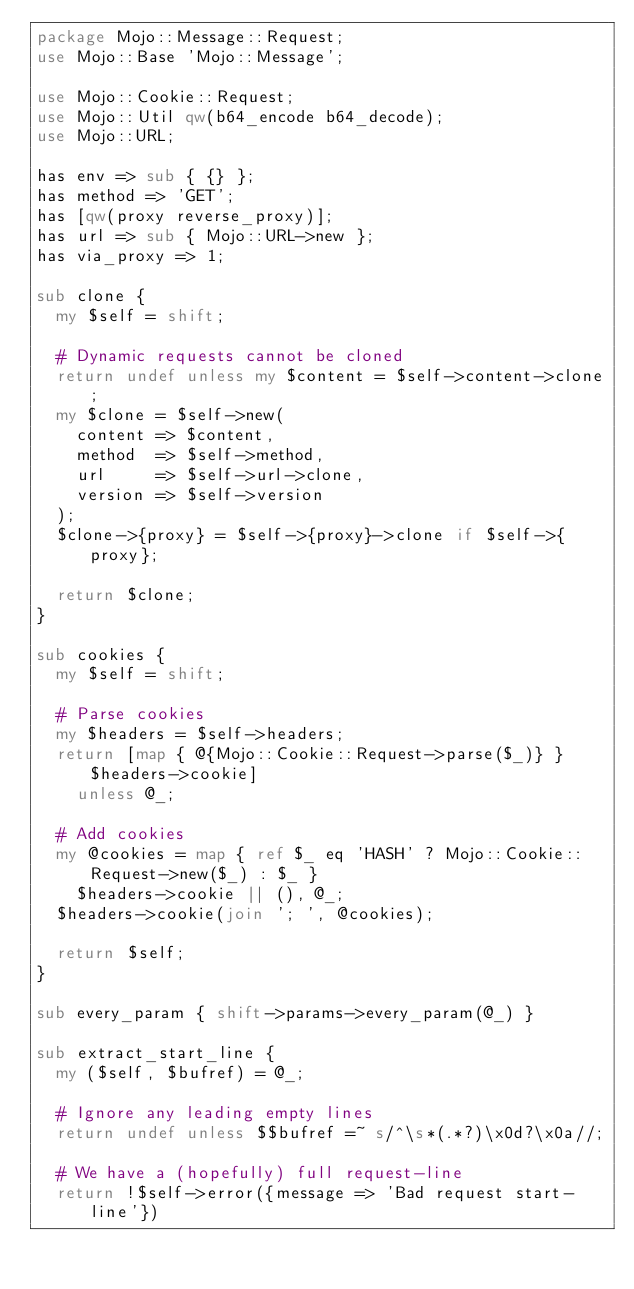<code> <loc_0><loc_0><loc_500><loc_500><_Perl_>package Mojo::Message::Request;
use Mojo::Base 'Mojo::Message';

use Mojo::Cookie::Request;
use Mojo::Util qw(b64_encode b64_decode);
use Mojo::URL;

has env => sub { {} };
has method => 'GET';
has [qw(proxy reverse_proxy)];
has url => sub { Mojo::URL->new };
has via_proxy => 1;

sub clone {
  my $self = shift;

  # Dynamic requests cannot be cloned
  return undef unless my $content = $self->content->clone;
  my $clone = $self->new(
    content => $content,
    method  => $self->method,
    url     => $self->url->clone,
    version => $self->version
  );
  $clone->{proxy} = $self->{proxy}->clone if $self->{proxy};

  return $clone;
}

sub cookies {
  my $self = shift;

  # Parse cookies
  my $headers = $self->headers;
  return [map { @{Mojo::Cookie::Request->parse($_)} } $headers->cookie]
    unless @_;

  # Add cookies
  my @cookies = map { ref $_ eq 'HASH' ? Mojo::Cookie::Request->new($_) : $_ }
    $headers->cookie || (), @_;
  $headers->cookie(join '; ', @cookies);

  return $self;
}

sub every_param { shift->params->every_param(@_) }

sub extract_start_line {
  my ($self, $bufref) = @_;

  # Ignore any leading empty lines
  return undef unless $$bufref =~ s/^\s*(.*?)\x0d?\x0a//;

  # We have a (hopefully) full request-line
  return !$self->error({message => 'Bad request start-line'})</code> 